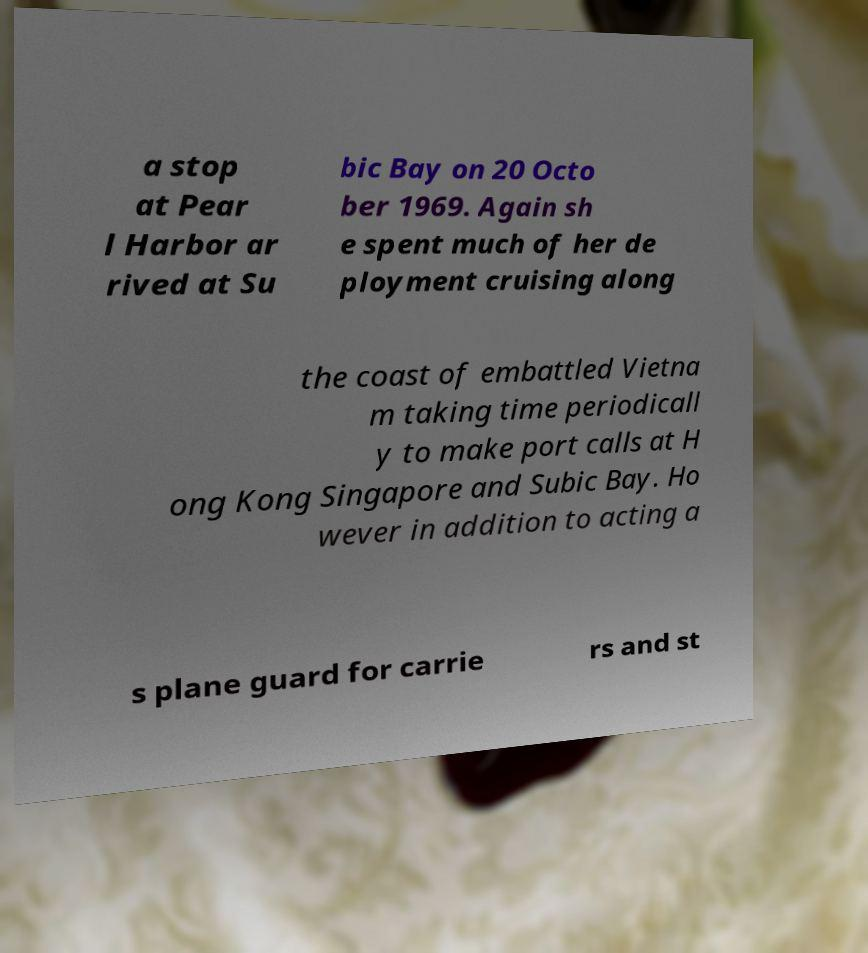What messages or text are displayed in this image? I need them in a readable, typed format. a stop at Pear l Harbor ar rived at Su bic Bay on 20 Octo ber 1969. Again sh e spent much of her de ployment cruising along the coast of embattled Vietna m taking time periodicall y to make port calls at H ong Kong Singapore and Subic Bay. Ho wever in addition to acting a s plane guard for carrie rs and st 